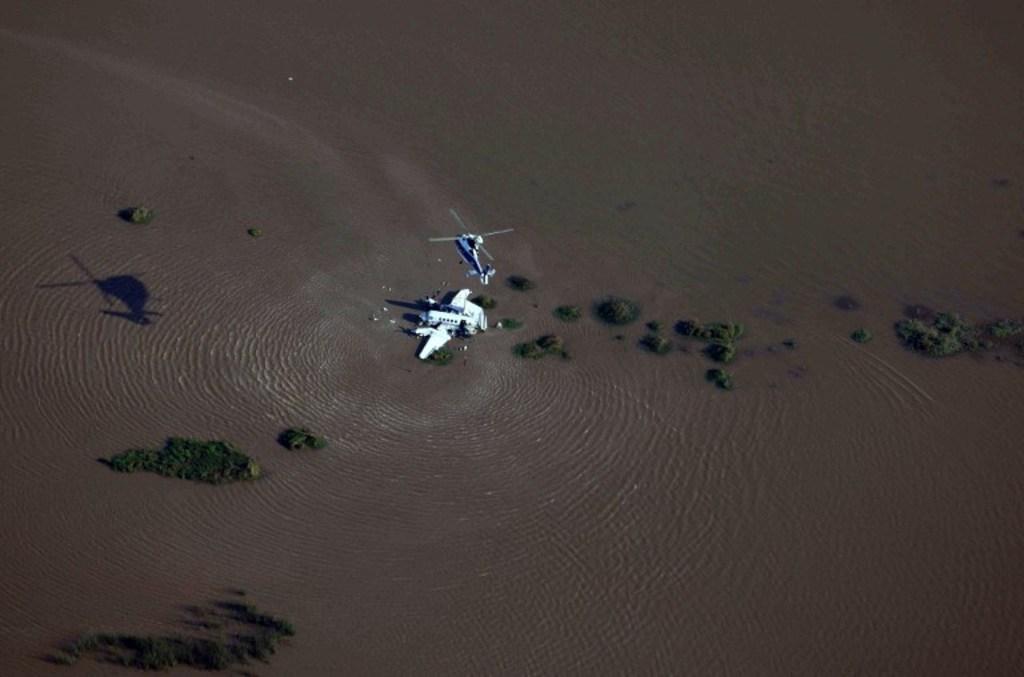Can you describe this image briefly? As we can see in the image there is water, trees, plants and buildings. 